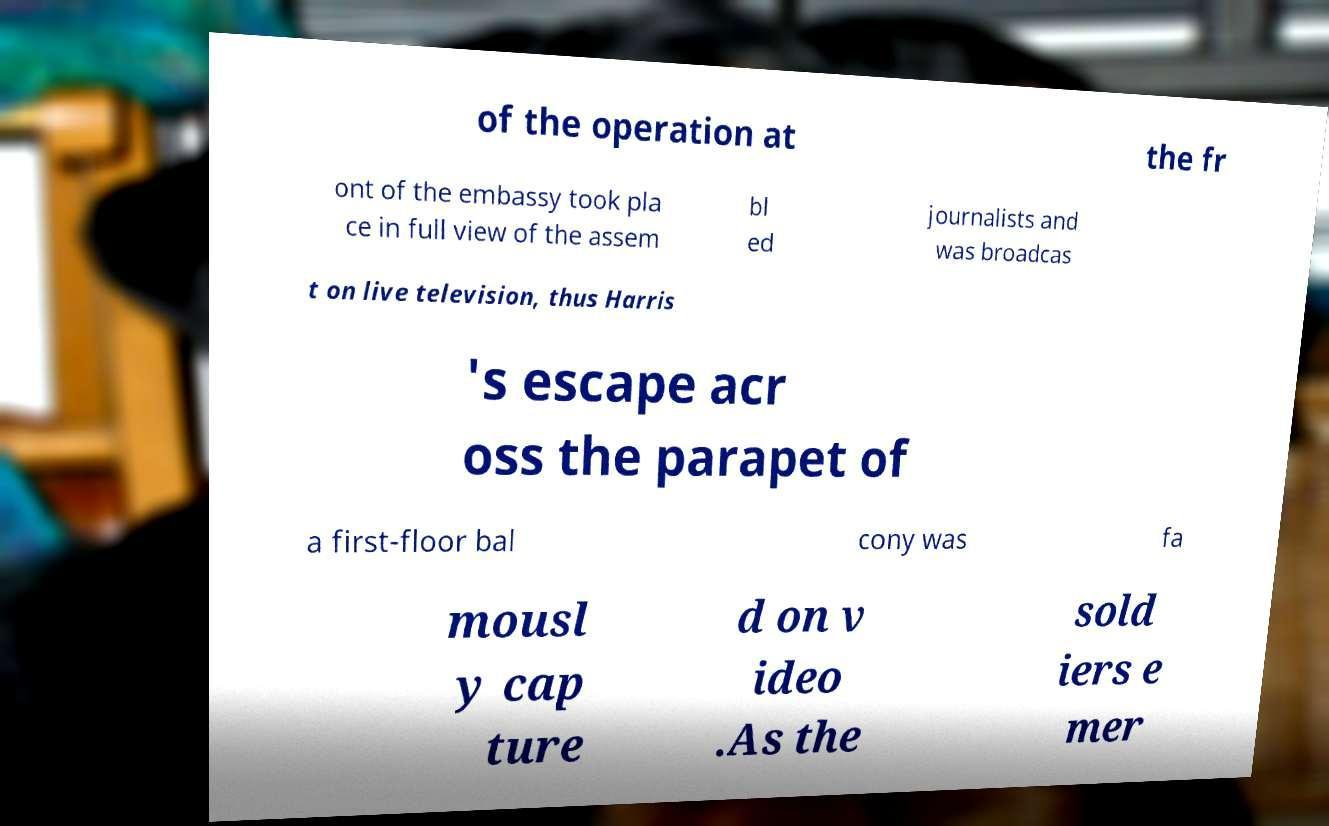For documentation purposes, I need the text within this image transcribed. Could you provide that? of the operation at the fr ont of the embassy took pla ce in full view of the assem bl ed journalists and was broadcas t on live television, thus Harris 's escape acr oss the parapet of a first-floor bal cony was fa mousl y cap ture d on v ideo .As the sold iers e mer 